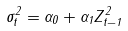Convert formula to latex. <formula><loc_0><loc_0><loc_500><loc_500>\sigma ^ { 2 } _ { t } = \alpha _ { 0 } + \alpha _ { 1 } Z _ { t - 1 } ^ { 2 }</formula> 